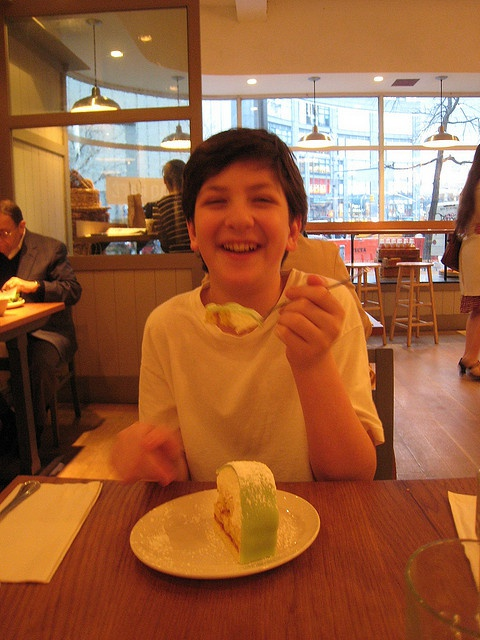Describe the objects in this image and their specific colors. I can see people in maroon, red, brown, and black tones, dining table in maroon, orange, and brown tones, people in maroon, black, and brown tones, cup in maroon, brown, and orange tones, and cake in maroon, olive, and orange tones in this image. 